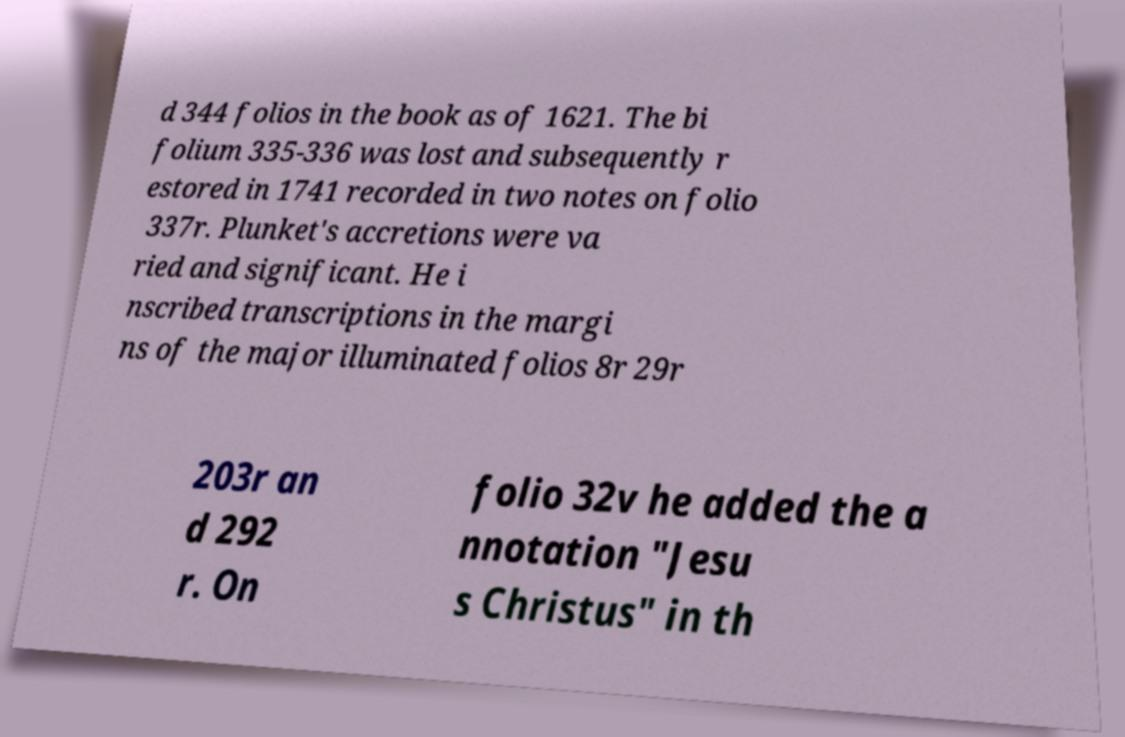Could you extract and type out the text from this image? d 344 folios in the book as of 1621. The bi folium 335-336 was lost and subsequently r estored in 1741 recorded in two notes on folio 337r. Plunket's accretions were va ried and significant. He i nscribed transcriptions in the margi ns of the major illuminated folios 8r 29r 203r an d 292 r. On folio 32v he added the a nnotation "Jesu s Christus" in th 